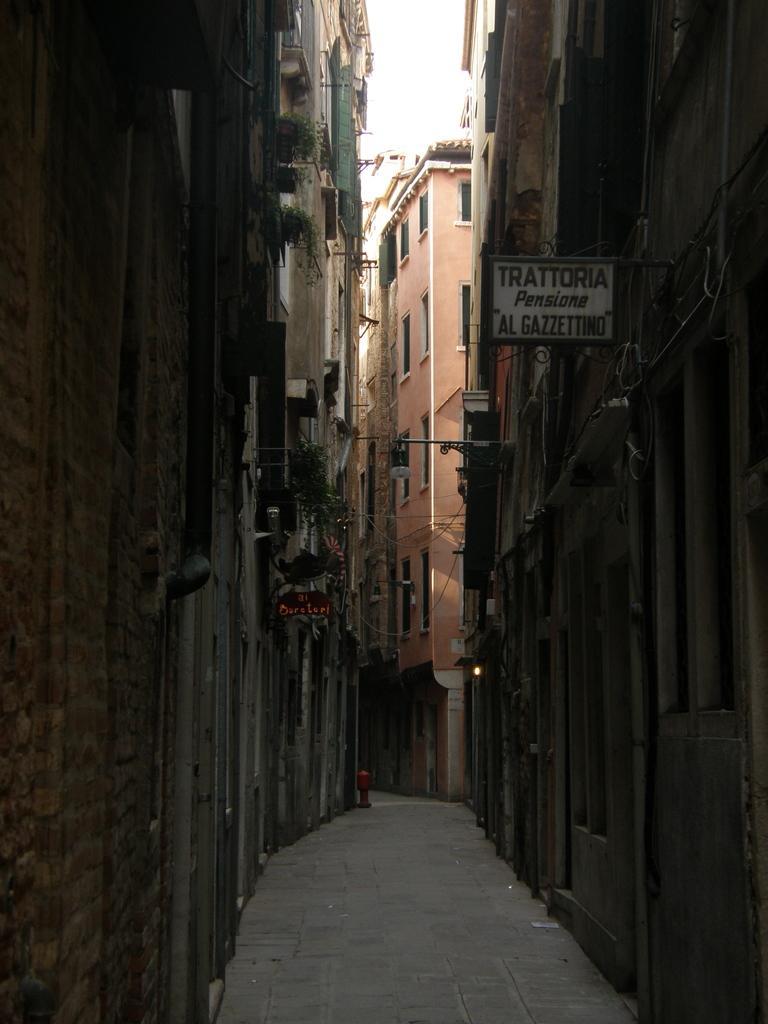Can you describe this image briefly? In this picture, we can see the path, buildings windows and some posters, poles, and we can see some plants and the sky. 